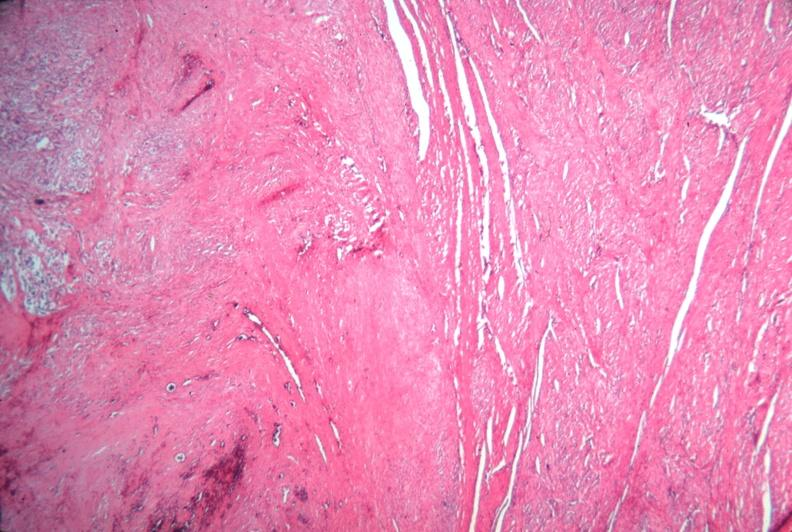where is this from?
Answer the question using a single word or phrase. Female reproductive system 